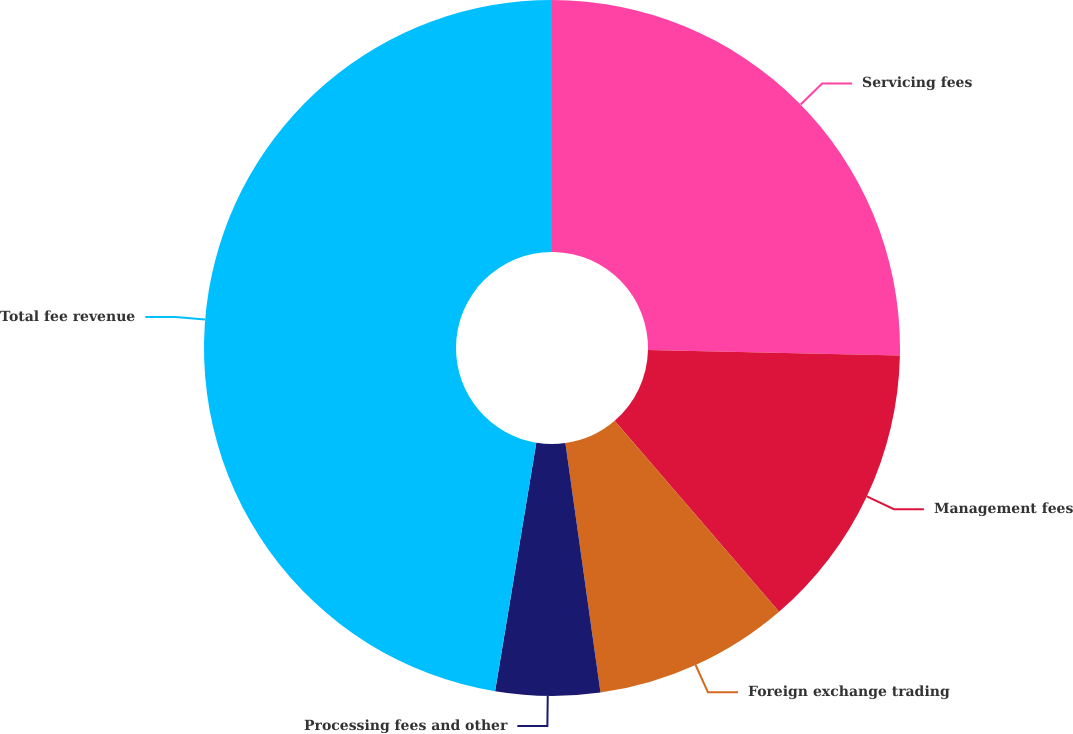<chart> <loc_0><loc_0><loc_500><loc_500><pie_chart><fcel>Servicing fees<fcel>Management fees<fcel>Foreign exchange trading<fcel>Processing fees and other<fcel>Total fee revenue<nl><fcel>25.34%<fcel>13.35%<fcel>9.09%<fcel>4.84%<fcel>47.39%<nl></chart> 